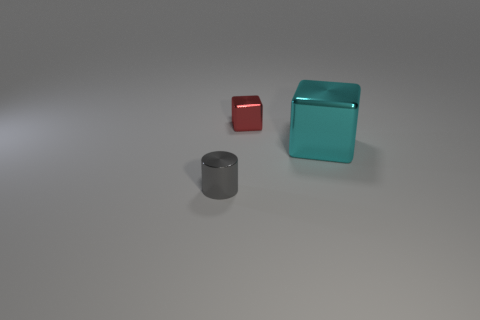Subtract all cylinders. How many objects are left? 2 Subtract all red blocks. How many blocks are left? 1 Subtract 1 cubes. How many cubes are left? 1 Add 1 shiny objects. How many shiny objects are left? 4 Add 3 tiny purple rubber cubes. How many tiny purple rubber cubes exist? 3 Add 2 small cyan matte things. How many objects exist? 5 Subtract 0 gray balls. How many objects are left? 3 Subtract all green blocks. Subtract all green cylinders. How many blocks are left? 2 Subtract all green blocks. How many cyan cylinders are left? 0 Subtract all tiny yellow objects. Subtract all tiny gray cylinders. How many objects are left? 2 